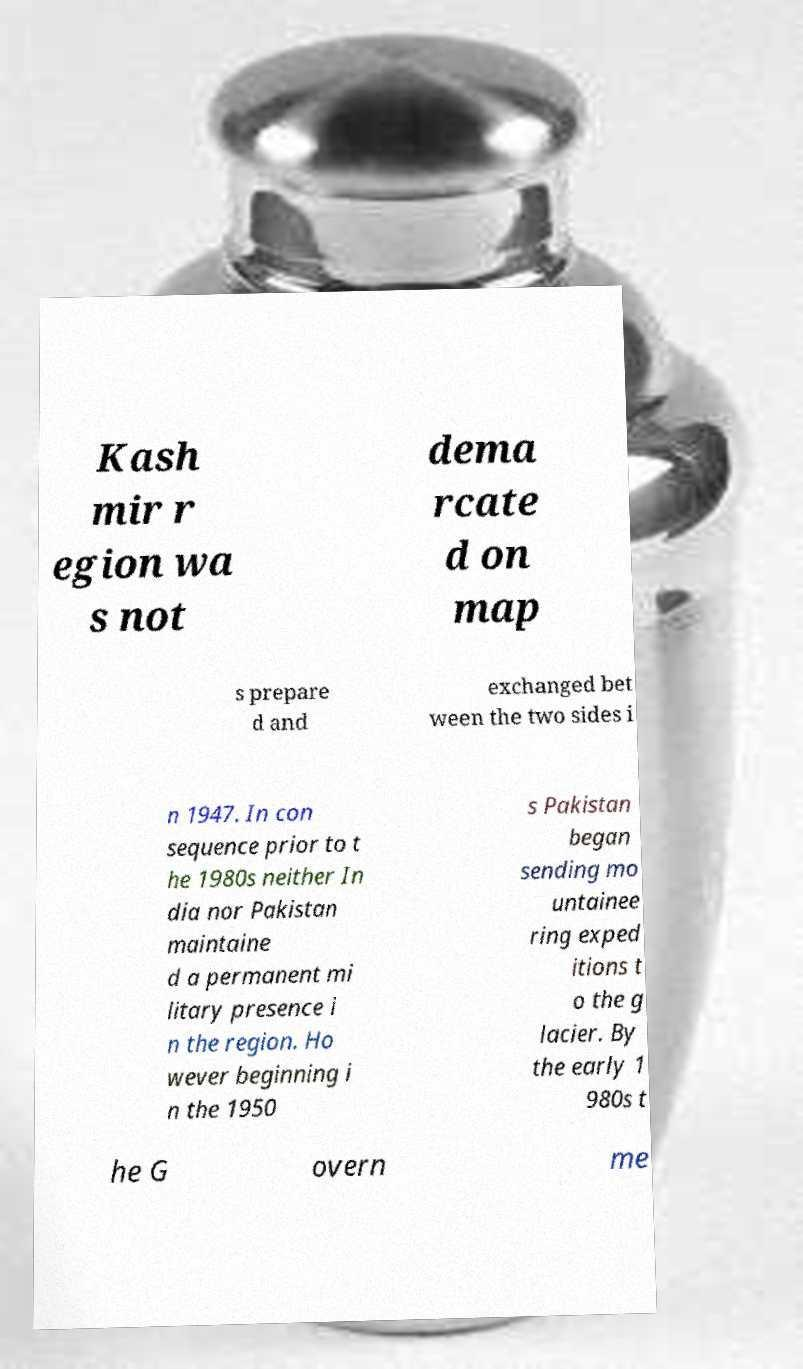There's text embedded in this image that I need extracted. Can you transcribe it verbatim? Kash mir r egion wa s not dema rcate d on map s prepare d and exchanged bet ween the two sides i n 1947. In con sequence prior to t he 1980s neither In dia nor Pakistan maintaine d a permanent mi litary presence i n the region. Ho wever beginning i n the 1950 s Pakistan began sending mo untainee ring exped itions t o the g lacier. By the early 1 980s t he G overn me 